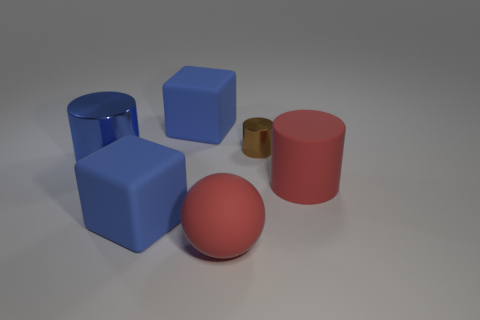There is a large matte thing that is behind the blue cylinder; is it the same color as the cube that is in front of the small cylinder?
Your response must be concise. Yes. Is the number of large blue blocks in front of the brown metal thing greater than the number of small gray matte cylinders?
Keep it short and to the point. Yes. What number of other objects are the same size as the blue metal object?
Make the answer very short. 4. What number of big red objects are on the right side of the small object and in front of the big rubber cylinder?
Provide a short and direct response. 0. Do the large cylinder that is on the left side of the big red sphere and the large red sphere have the same material?
Ensure brevity in your answer.  No. There is a red rubber thing that is behind the large rubber cube that is to the left of the blue rubber thing behind the small metallic object; what shape is it?
Provide a short and direct response. Cylinder. Are there the same number of brown shiny cylinders that are on the right side of the small metallic cylinder and large red matte balls on the right side of the big red rubber cylinder?
Your answer should be very brief. Yes. There is a metal thing that is the same size as the sphere; what is its color?
Give a very brief answer. Blue. How many small things are blue cylinders or red matte objects?
Offer a terse response. 0. There is a thing that is behind the large blue metallic thing and left of the small object; what material is it?
Your answer should be very brief. Rubber. 